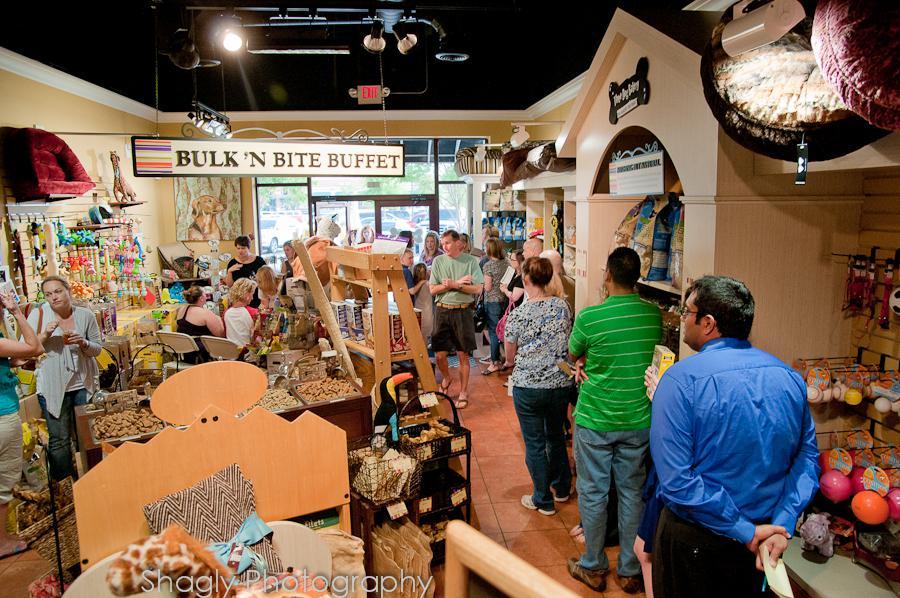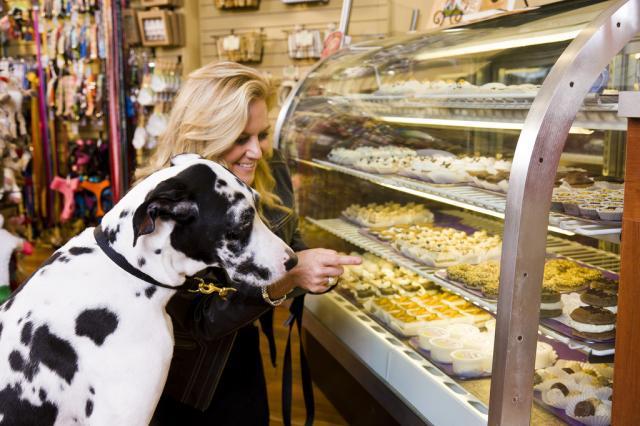The first image is the image on the left, the second image is the image on the right. Examine the images to the left and right. Is the description "A white and black dog is standing near a glass case in one  of the images." accurate? Answer yes or no. Yes. 